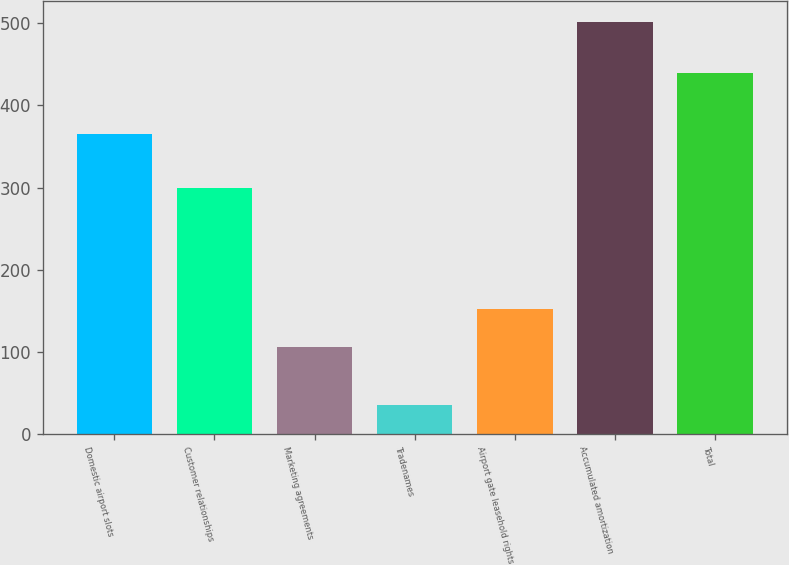Convert chart to OTSL. <chart><loc_0><loc_0><loc_500><loc_500><bar_chart><fcel>Domestic airport slots<fcel>Customer relationships<fcel>Marketing agreements<fcel>Tradenames<fcel>Airport gate leasehold rights<fcel>Accumulated amortization<fcel>Total<nl><fcel>365<fcel>300<fcel>105<fcel>35<fcel>151.7<fcel>502<fcel>440<nl></chart> 